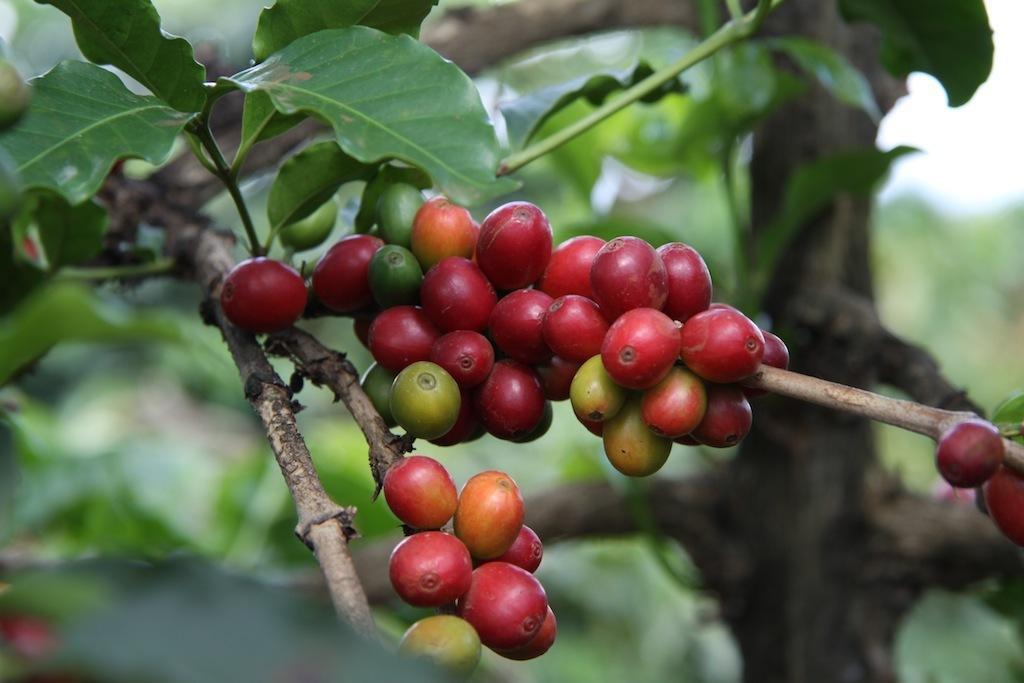Describe this image in one or two sentences. In this picture we can see red cherries on the tree. Behind there is a blur green background. 